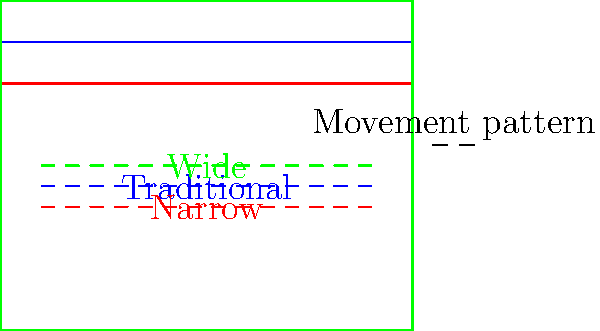Based on the diagram showing three different football pitch layouts (traditional, narrow, and wide) and their associated player movement patterns, analyze how the efficiency of player movements might be affected. Consider factors such as distance covered, space utilization, and potential impact on gameplay. Which layout would likely result in the most efficient use of space and energy for players? To analyze the efficiency of different football pitch layouts and their impact on player movement patterns, we need to consider several factors:

1. Distance covered:
   - Traditional pitch: Players cover a moderate distance.
   - Narrow pitch: Players cover less lateral distance but may need to make more vertical runs.
   - Wide pitch: Players cover more lateral distance, potentially increasing overall distance traveled.

2. Space utilization:
   - Traditional pitch: Balanced use of space, allowing for various tactical approaches.
   - Narrow pitch: Less width, which may lead to congestion in central areas.
   - Wide pitch: More space on the wings, potentially spreading out play.

3. Energy expenditure:
   - Traditional pitch: Moderate energy use, balancing lateral and vertical movements.
   - Narrow pitch: Potentially less energy spent on wide runs, but more on short, intense movements in tight spaces.
   - Wide pitch: More energy spent on covering larger lateral distances.

4. Tactical implications:
   - Traditional pitch: Versatile, allowing for various playing styles.
   - Narrow pitch: May favor direct, vertical play and high-pressure tactics.
   - Wide pitch: Could encourage more wing play and expansive passing.

5. Player positioning:
   - Traditional pitch: Balanced positioning across the field.
   - Narrow pitch: Players may cluster more centrally, reducing spacing between them.
   - Wide pitch: Players can spread out more, potentially creating larger gaps between positions.

Considering these factors, the most efficient layout would likely be the traditional pitch. It offers a balance between lateral and vertical movement, allows for versatile tactics, and provides moderate space utilization without excessive energy expenditure. The traditional layout enables players to cover optimal distances while maintaining effective positioning and spacing.

The narrow pitch might lead to more congestion and potentially higher-intensity, shorter movements, which could be less efficient over the course of a full match. The wide pitch, while offering more space, could result in players covering unnecessarily large distances, leading to increased fatigue.
Answer: Traditional pitch layout 